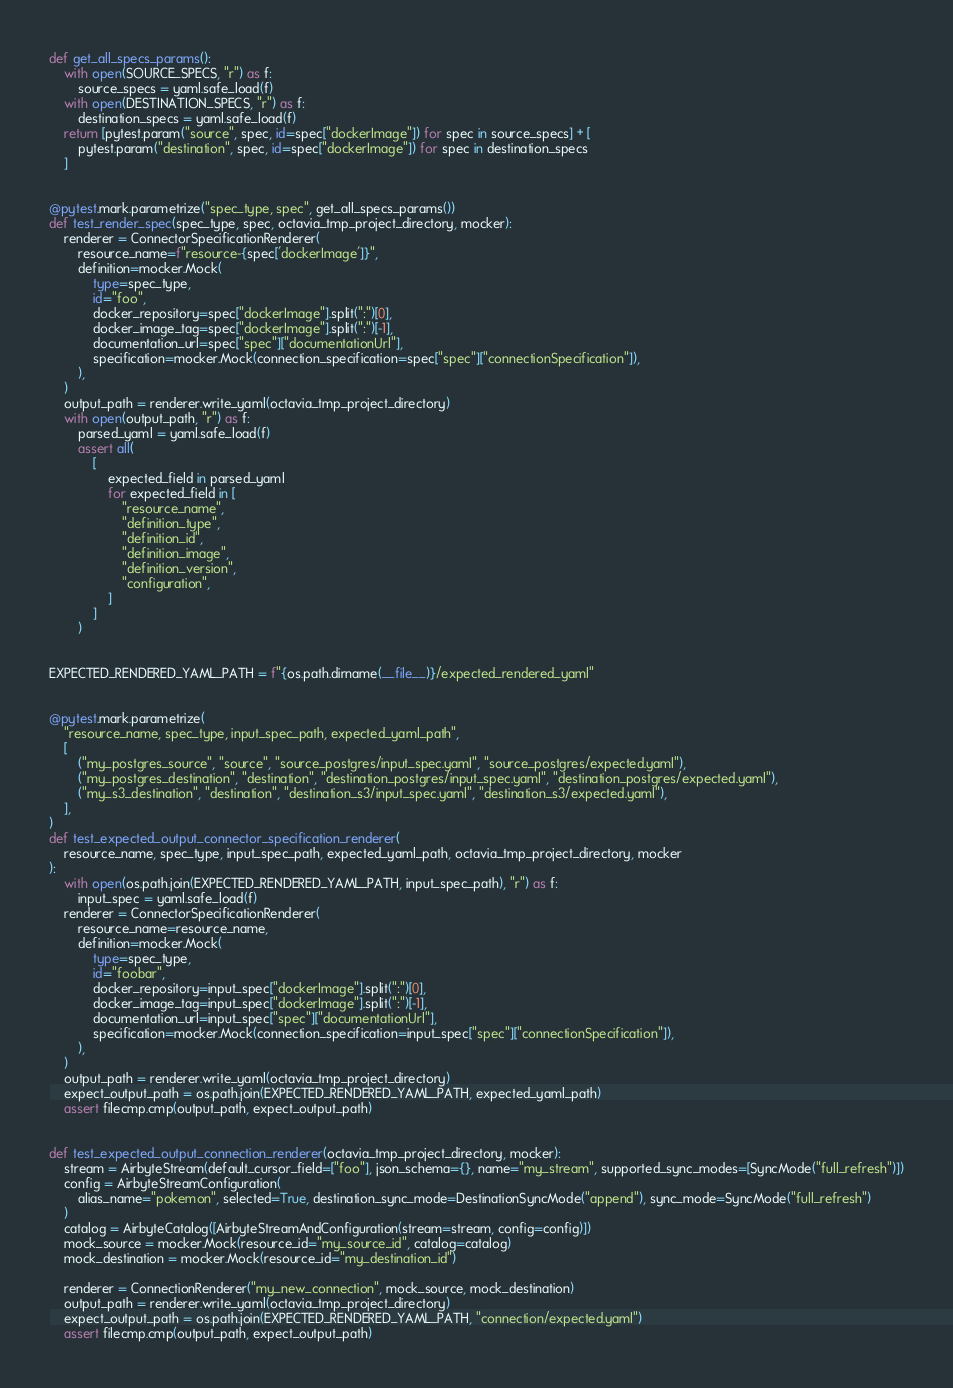Convert code to text. <code><loc_0><loc_0><loc_500><loc_500><_Python_>def get_all_specs_params():
    with open(SOURCE_SPECS, "r") as f:
        source_specs = yaml.safe_load(f)
    with open(DESTINATION_SPECS, "r") as f:
        destination_specs = yaml.safe_load(f)
    return [pytest.param("source", spec, id=spec["dockerImage"]) for spec in source_specs] + [
        pytest.param("destination", spec, id=spec["dockerImage"]) for spec in destination_specs
    ]


@pytest.mark.parametrize("spec_type, spec", get_all_specs_params())
def test_render_spec(spec_type, spec, octavia_tmp_project_directory, mocker):
    renderer = ConnectorSpecificationRenderer(
        resource_name=f"resource-{spec['dockerImage']}",
        definition=mocker.Mock(
            type=spec_type,
            id="foo",
            docker_repository=spec["dockerImage"].split(":")[0],
            docker_image_tag=spec["dockerImage"].split(":")[-1],
            documentation_url=spec["spec"]["documentationUrl"],
            specification=mocker.Mock(connection_specification=spec["spec"]["connectionSpecification"]),
        ),
    )
    output_path = renderer.write_yaml(octavia_tmp_project_directory)
    with open(output_path, "r") as f:
        parsed_yaml = yaml.safe_load(f)
        assert all(
            [
                expected_field in parsed_yaml
                for expected_field in [
                    "resource_name",
                    "definition_type",
                    "definition_id",
                    "definition_image",
                    "definition_version",
                    "configuration",
                ]
            ]
        )


EXPECTED_RENDERED_YAML_PATH = f"{os.path.dirname(__file__)}/expected_rendered_yaml"


@pytest.mark.parametrize(
    "resource_name, spec_type, input_spec_path, expected_yaml_path",
    [
        ("my_postgres_source", "source", "source_postgres/input_spec.yaml", "source_postgres/expected.yaml"),
        ("my_postgres_destination", "destination", "destination_postgres/input_spec.yaml", "destination_postgres/expected.yaml"),
        ("my_s3_destination", "destination", "destination_s3/input_spec.yaml", "destination_s3/expected.yaml"),
    ],
)
def test_expected_output_connector_specification_renderer(
    resource_name, spec_type, input_spec_path, expected_yaml_path, octavia_tmp_project_directory, mocker
):
    with open(os.path.join(EXPECTED_RENDERED_YAML_PATH, input_spec_path), "r") as f:
        input_spec = yaml.safe_load(f)
    renderer = ConnectorSpecificationRenderer(
        resource_name=resource_name,
        definition=mocker.Mock(
            type=spec_type,
            id="foobar",
            docker_repository=input_spec["dockerImage"].split(":")[0],
            docker_image_tag=input_spec["dockerImage"].split(":")[-1],
            documentation_url=input_spec["spec"]["documentationUrl"],
            specification=mocker.Mock(connection_specification=input_spec["spec"]["connectionSpecification"]),
        ),
    )
    output_path = renderer.write_yaml(octavia_tmp_project_directory)
    expect_output_path = os.path.join(EXPECTED_RENDERED_YAML_PATH, expected_yaml_path)
    assert filecmp.cmp(output_path, expect_output_path)


def test_expected_output_connection_renderer(octavia_tmp_project_directory, mocker):
    stream = AirbyteStream(default_cursor_field=["foo"], json_schema={}, name="my_stream", supported_sync_modes=[SyncMode("full_refresh")])
    config = AirbyteStreamConfiguration(
        alias_name="pokemon", selected=True, destination_sync_mode=DestinationSyncMode("append"), sync_mode=SyncMode("full_refresh")
    )
    catalog = AirbyteCatalog([AirbyteStreamAndConfiguration(stream=stream, config=config)])
    mock_source = mocker.Mock(resource_id="my_source_id", catalog=catalog)
    mock_destination = mocker.Mock(resource_id="my_destination_id")

    renderer = ConnectionRenderer("my_new_connection", mock_source, mock_destination)
    output_path = renderer.write_yaml(octavia_tmp_project_directory)
    expect_output_path = os.path.join(EXPECTED_RENDERED_YAML_PATH, "connection/expected.yaml")
    assert filecmp.cmp(output_path, expect_output_path)
</code> 